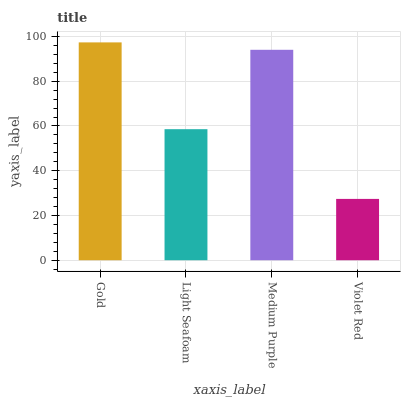Is Violet Red the minimum?
Answer yes or no. Yes. Is Gold the maximum?
Answer yes or no. Yes. Is Light Seafoam the minimum?
Answer yes or no. No. Is Light Seafoam the maximum?
Answer yes or no. No. Is Gold greater than Light Seafoam?
Answer yes or no. Yes. Is Light Seafoam less than Gold?
Answer yes or no. Yes. Is Light Seafoam greater than Gold?
Answer yes or no. No. Is Gold less than Light Seafoam?
Answer yes or no. No. Is Medium Purple the high median?
Answer yes or no. Yes. Is Light Seafoam the low median?
Answer yes or no. Yes. Is Light Seafoam the high median?
Answer yes or no. No. Is Gold the low median?
Answer yes or no. No. 